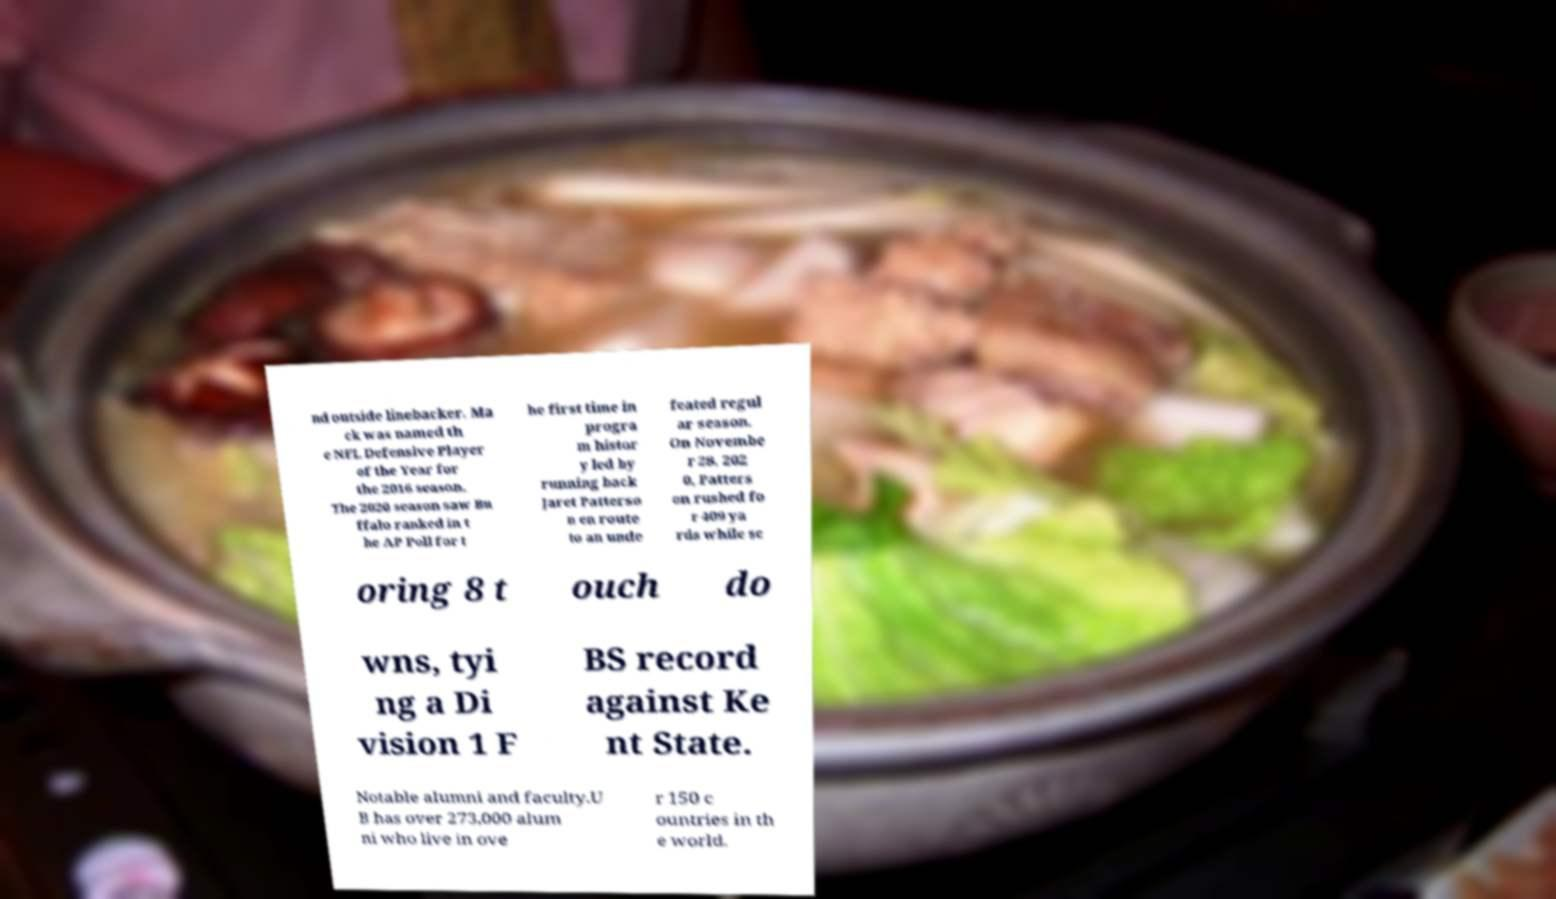Please identify and transcribe the text found in this image. nd outside linebacker. Ma ck was named th e NFL Defensive Player of the Year for the 2016 season. The 2020 season saw Bu ffalo ranked in t he AP Poll for t he first time in progra m histor y led by running back Jaret Patterso n en route to an unde feated regul ar season. On Novembe r 28, 202 0, Patters on rushed fo r 409 ya rds while sc oring 8 t ouch do wns, tyi ng a Di vision 1 F BS record against Ke nt State. Notable alumni and faculty.U B has over 273,000 alum ni who live in ove r 150 c ountries in th e world. 